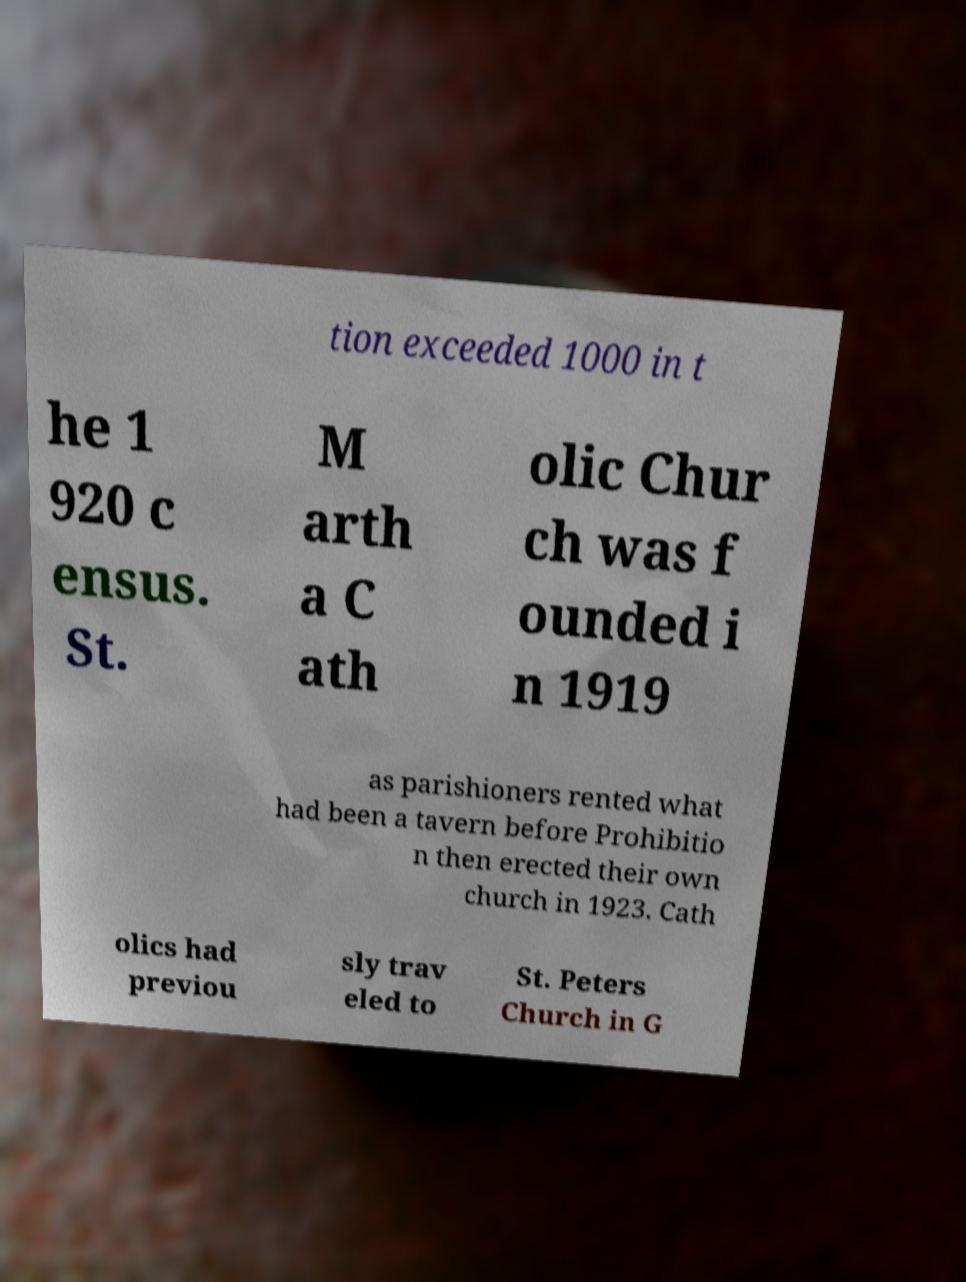Please read and relay the text visible in this image. What does it say? tion exceeded 1000 in t he 1 920 c ensus. St. M arth a C ath olic Chur ch was f ounded i n 1919 as parishioners rented what had been a tavern before Prohibitio n then erected their own church in 1923. Cath olics had previou sly trav eled to St. Peters Church in G 